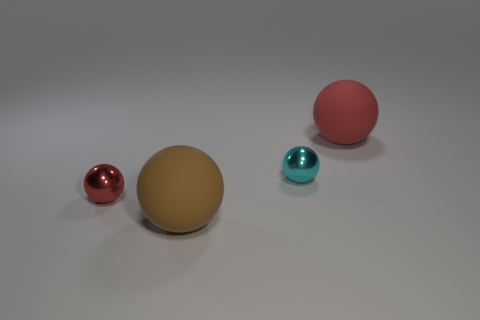Add 3 small cyan balls. How many objects exist? 7 Subtract all green matte things. Subtract all small metallic objects. How many objects are left? 2 Add 4 large red spheres. How many large red spheres are left? 5 Add 1 big gray cylinders. How many big gray cylinders exist? 1 Subtract 2 red spheres. How many objects are left? 2 